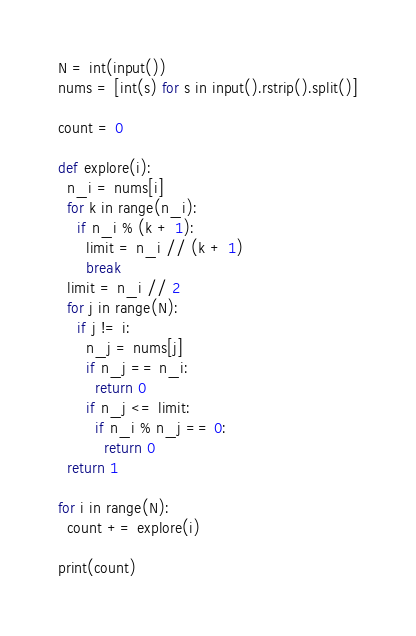Convert code to text. <code><loc_0><loc_0><loc_500><loc_500><_Python_>N = int(input())
nums = [int(s) for s in input().rstrip().split()]

count = 0

def explore(i):
  n_i = nums[i]
  for k in range(n_i):
    if n_i % (k + 1):
      limit = n_i // (k + 1)
      break
  limit = n_i // 2
  for j in range(N):
    if j != i:
      n_j = nums[j]
      if n_j == n_i:
        return 0
      if n_j <= limit:
        if n_i % n_j == 0:
          return 0
  return 1

for i in range(N):
  count += explore(i)

print(count)</code> 